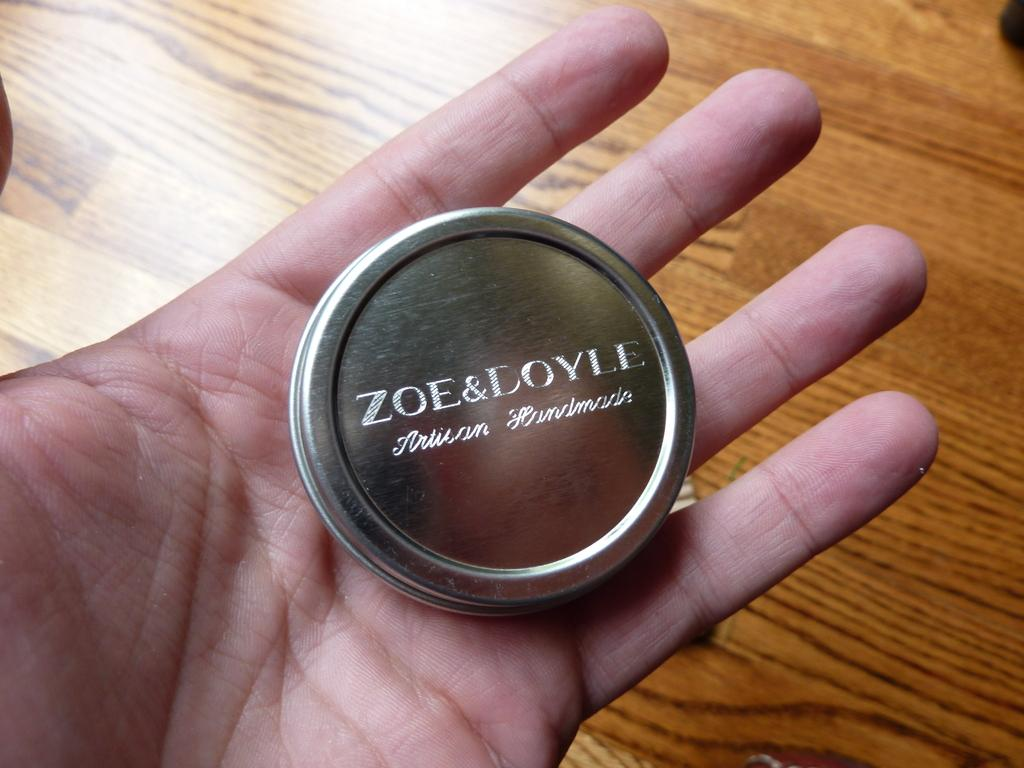What is being held by the person's hand in the image? There is a person's hand holding a box in the image. What type of material is the floor made of in the image? The floor in the image is made of wood. What type of laborer is working in the mine in the image? There is no mine or laborer present in the image; it only shows a person's hand holding a box and a wooden floor. 